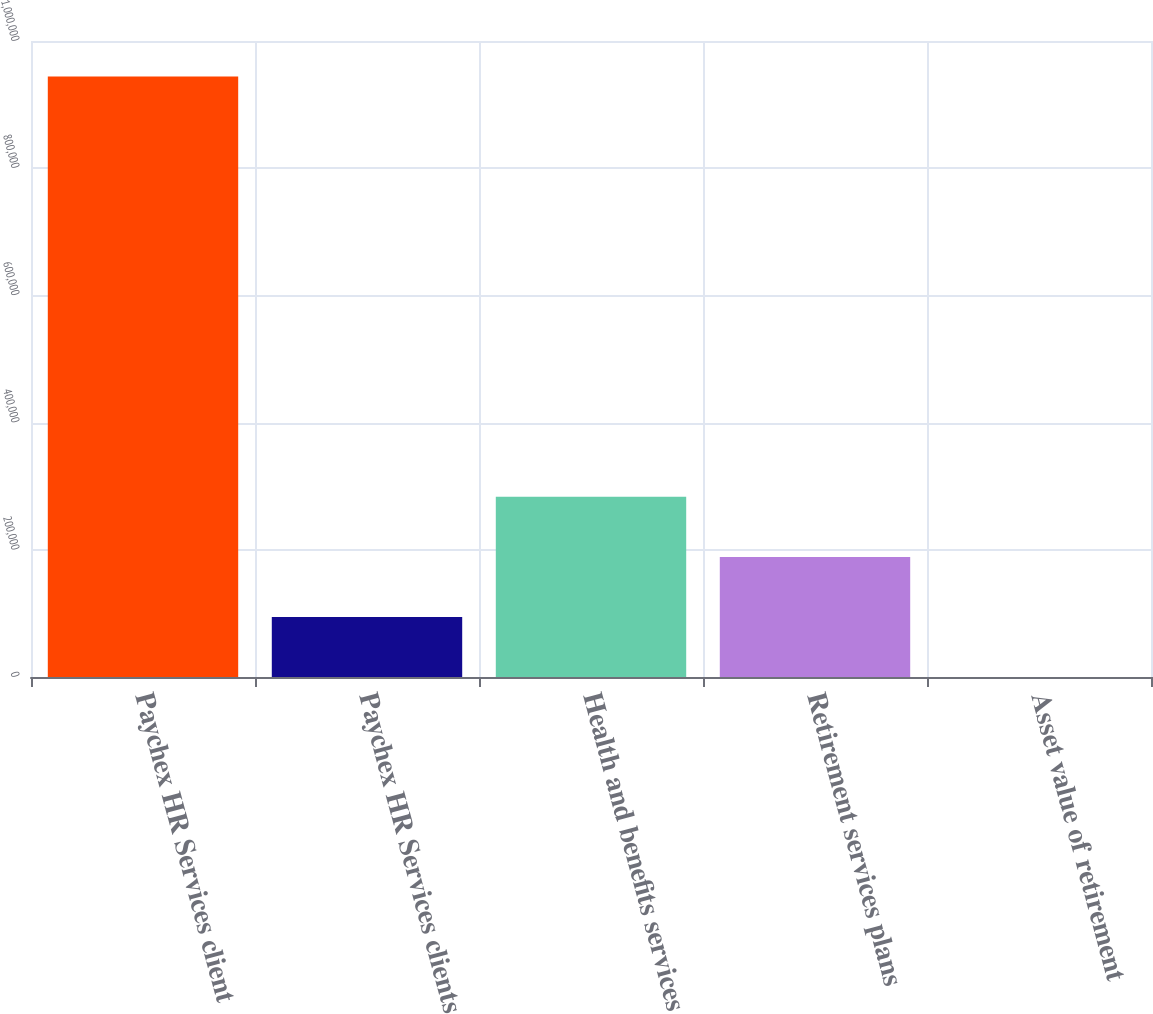Convert chart to OTSL. <chart><loc_0><loc_0><loc_500><loc_500><bar_chart><fcel>Paychex HR Services client<fcel>Paychex HR Services clients<fcel>Health and benefits services<fcel>Retirement services plans<fcel>Asset value of retirement<nl><fcel>944000<fcel>94421.2<fcel>283217<fcel>188819<fcel>23.6<nl></chart> 